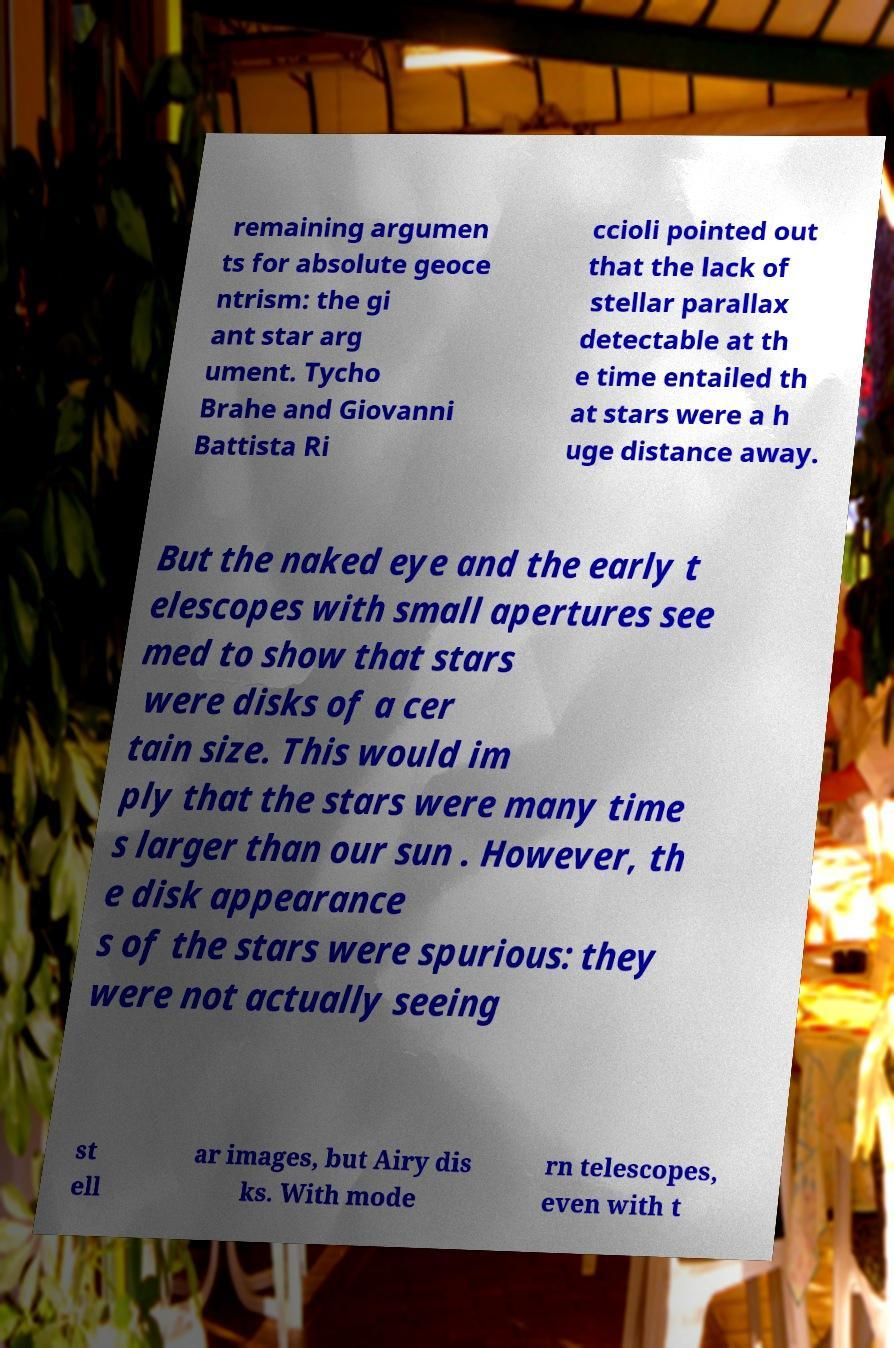Can you accurately transcribe the text from the provided image for me? remaining argumen ts for absolute geoce ntrism: the gi ant star arg ument. Tycho Brahe and Giovanni Battista Ri ccioli pointed out that the lack of stellar parallax detectable at th e time entailed th at stars were a h uge distance away. But the naked eye and the early t elescopes with small apertures see med to show that stars were disks of a cer tain size. This would im ply that the stars were many time s larger than our sun . However, th e disk appearance s of the stars were spurious: they were not actually seeing st ell ar images, but Airy dis ks. With mode rn telescopes, even with t 